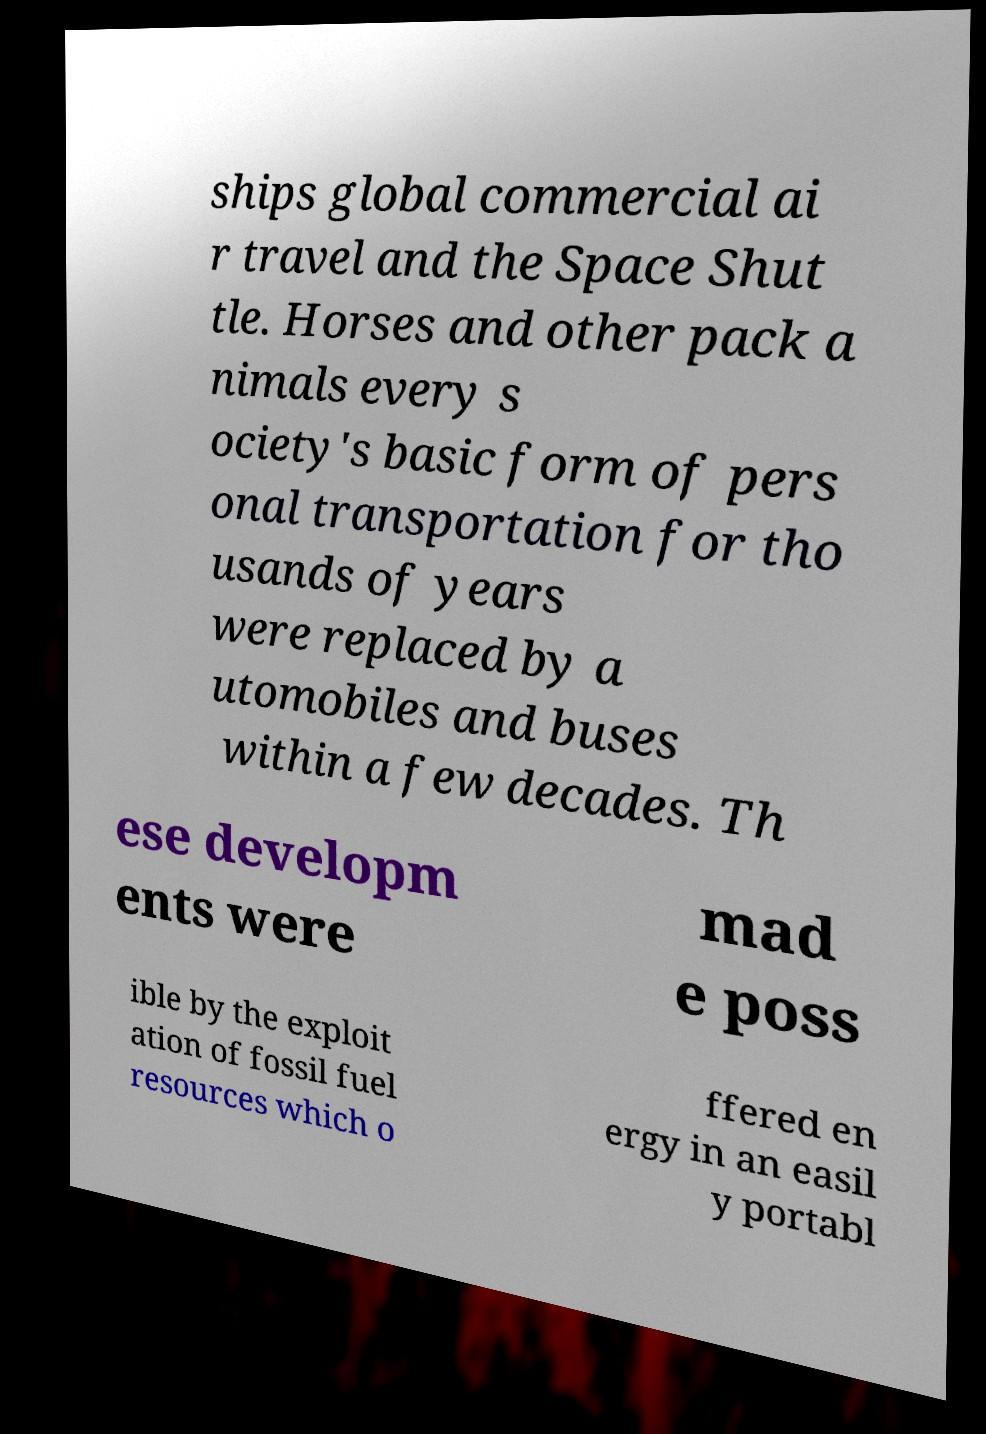Could you extract and type out the text from this image? ships global commercial ai r travel and the Space Shut tle. Horses and other pack a nimals every s ociety's basic form of pers onal transportation for tho usands of years were replaced by a utomobiles and buses within a few decades. Th ese developm ents were mad e poss ible by the exploit ation of fossil fuel resources which o ffered en ergy in an easil y portabl 